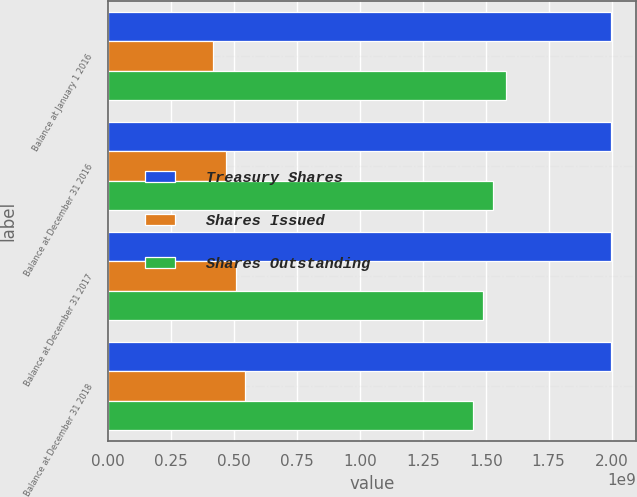<chart> <loc_0><loc_0><loc_500><loc_500><stacked_bar_chart><ecel><fcel>Balance at January 1 2016<fcel>Balance at December 31 2016<fcel>Balance at December 31 2017<fcel>Balance at December 31 2018<nl><fcel>Treasury Shares<fcel>1.99654e+09<fcel>1.99654e+09<fcel>1.99654e+09<fcel>1.99654e+09<nl><fcel>Shares Issued<fcel>4.16505e+08<fcel>4.68172e+08<fcel>5.08402e+08<fcel>5.45538e+08<nl><fcel>Shares Outstanding<fcel>1.58003e+09<fcel>1.52837e+09<fcel>1.48814e+09<fcel>1.451e+09<nl></chart> 